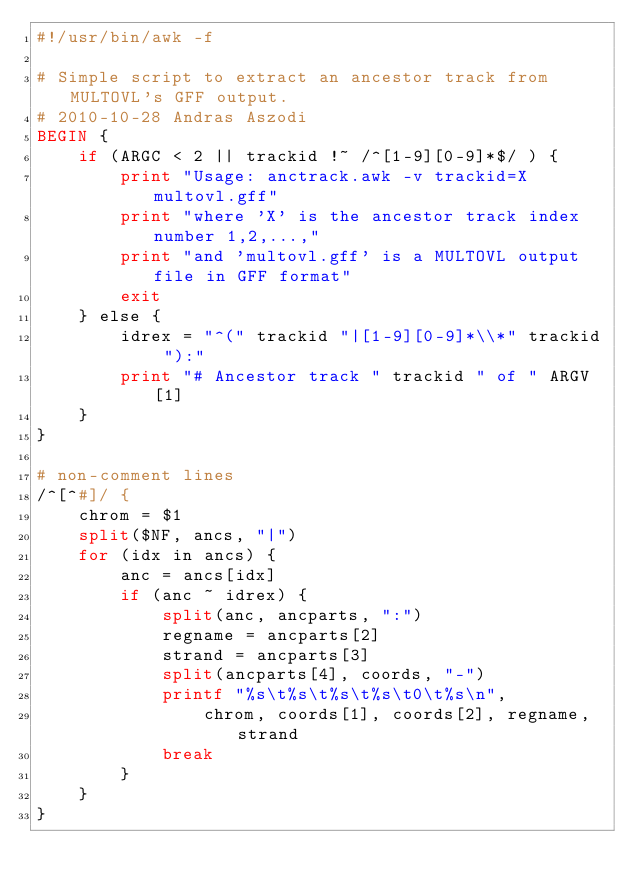Convert code to text. <code><loc_0><loc_0><loc_500><loc_500><_Awk_>#!/usr/bin/awk -f

# Simple script to extract an ancestor track from MULTOVL's GFF output.
# 2010-10-28 Andras Aszodi
BEGIN {
    if (ARGC < 2 || trackid !~ /^[1-9][0-9]*$/ ) {
        print "Usage: anctrack.awk -v trackid=X multovl.gff"
        print "where 'X' is the ancestor track index number 1,2,...,"
        print "and 'multovl.gff' is a MULTOVL output file in GFF format"
        exit
    } else {
        idrex = "^(" trackid "|[1-9][0-9]*\\*" trackid "):"
        print "# Ancestor track " trackid " of " ARGV[1]
    }
}

# non-comment lines
/^[^#]/ {
    chrom = $1
    split($NF, ancs, "|")
    for (idx in ancs) {
        anc = ancs[idx]
        if (anc ~ idrex) {
            split(anc, ancparts, ":")
            regname = ancparts[2]
            strand = ancparts[3]
            split(ancparts[4], coords, "-")
            printf "%s\t%s\t%s\t%s\t0\t%s\n", 
                chrom, coords[1], coords[2], regname, strand
            break
        }
    }
}
</code> 